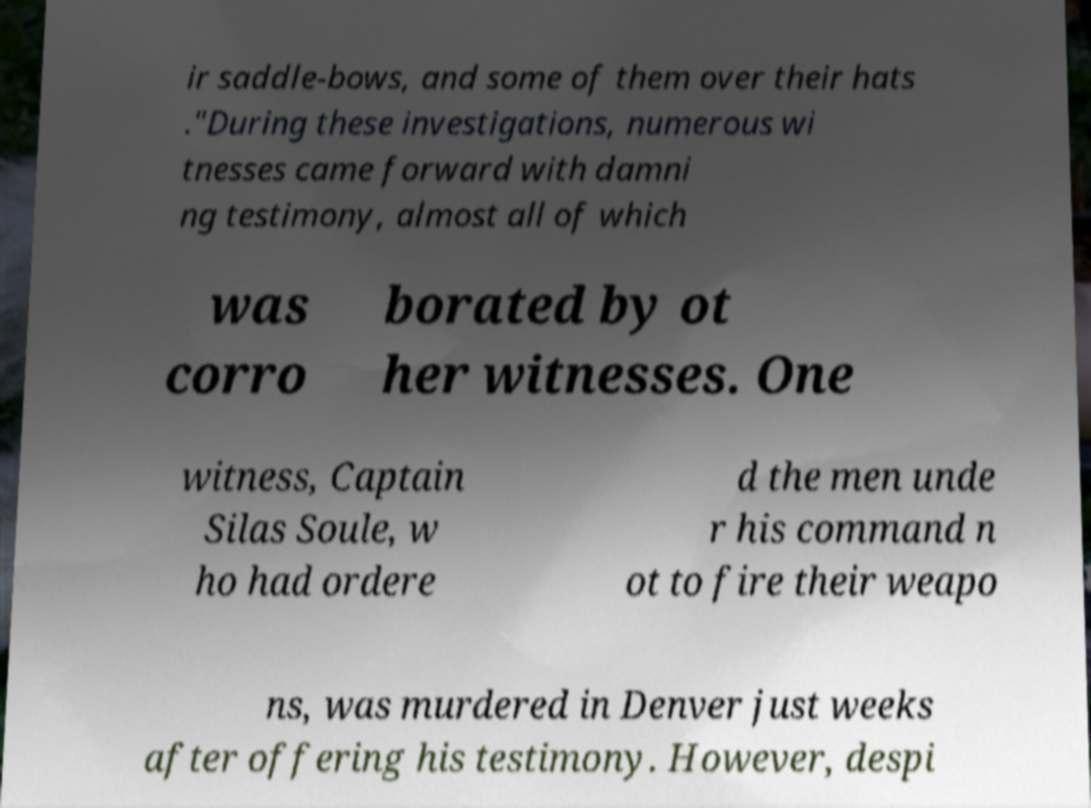Can you accurately transcribe the text from the provided image for me? ir saddle-bows, and some of them over their hats ."During these investigations, numerous wi tnesses came forward with damni ng testimony, almost all of which was corro borated by ot her witnesses. One witness, Captain Silas Soule, w ho had ordere d the men unde r his command n ot to fire their weapo ns, was murdered in Denver just weeks after offering his testimony. However, despi 